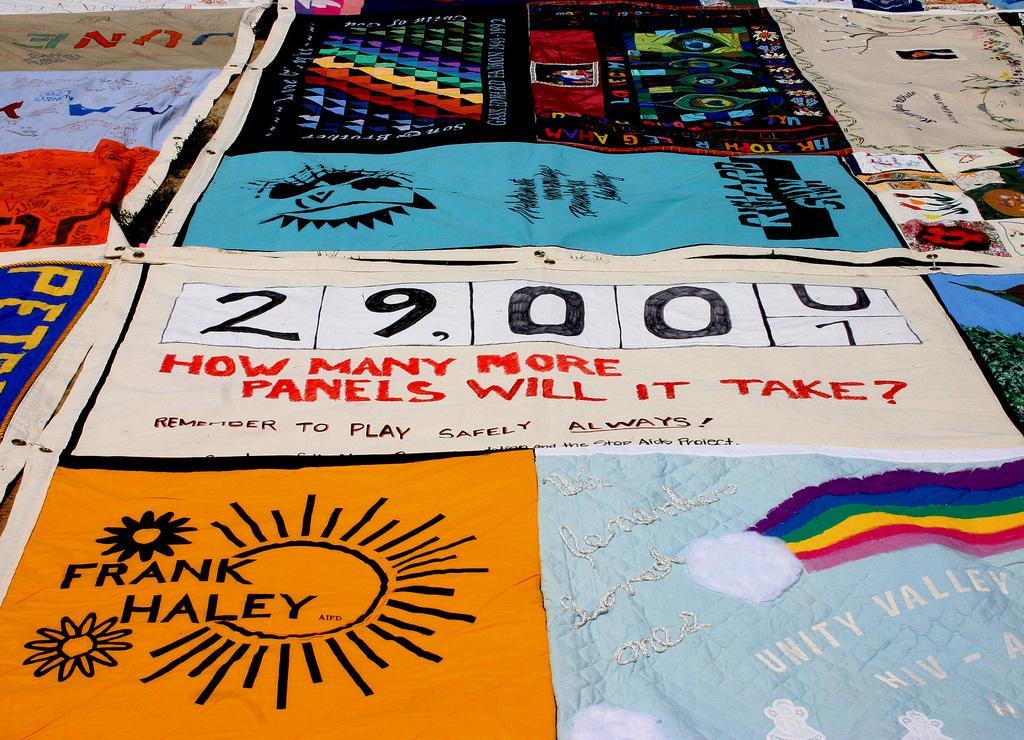Can you describe this image briefly? In the foreground of this image, there are banners on the surface. 